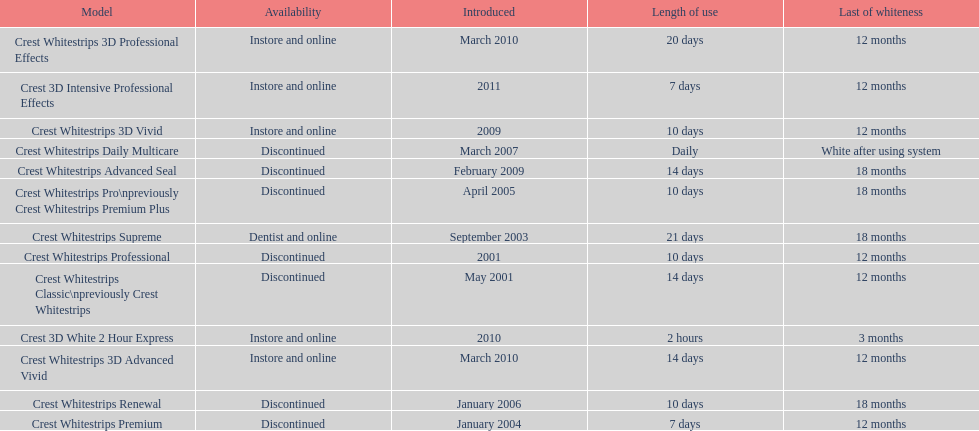How many models require less than a week of use? 2. 